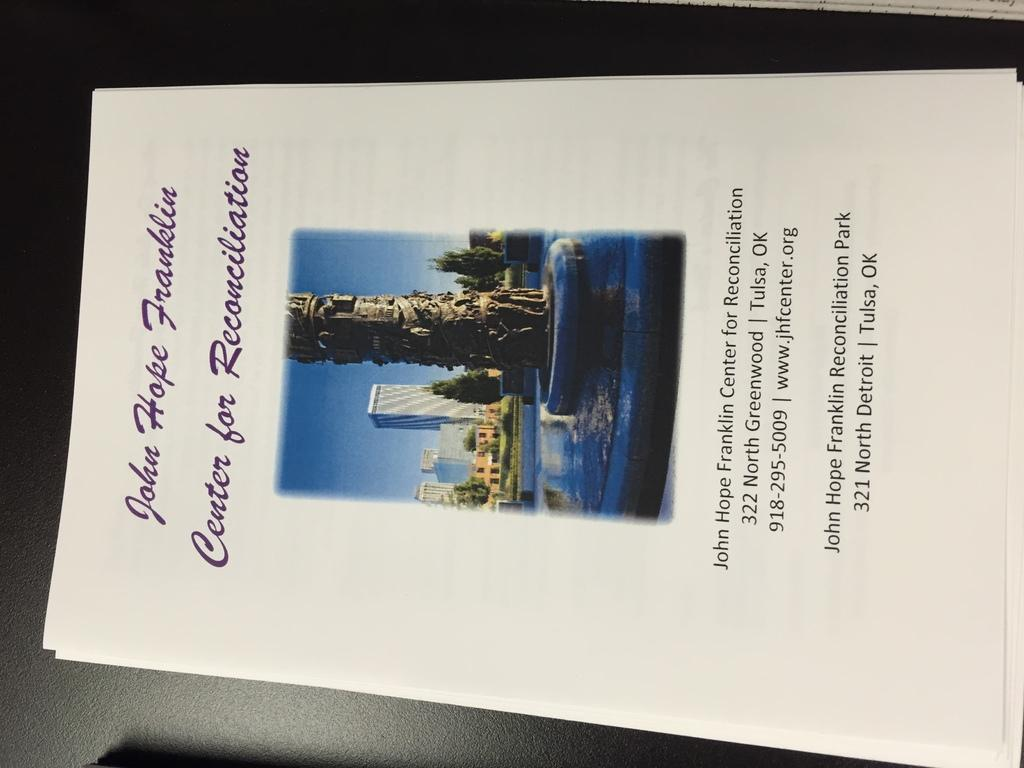<image>
Render a clear and concise summary of the photo. Booklet for John Hope Franklin showing the address and phone. 